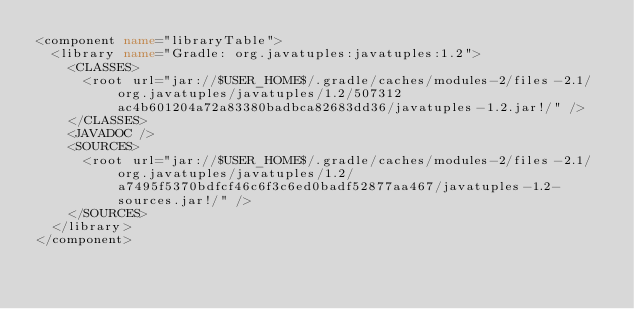<code> <loc_0><loc_0><loc_500><loc_500><_XML_><component name="libraryTable">
  <library name="Gradle: org.javatuples:javatuples:1.2">
    <CLASSES>
      <root url="jar://$USER_HOME$/.gradle/caches/modules-2/files-2.1/org.javatuples/javatuples/1.2/507312ac4b601204a72a83380badbca82683dd36/javatuples-1.2.jar!/" />
    </CLASSES>
    <JAVADOC />
    <SOURCES>
      <root url="jar://$USER_HOME$/.gradle/caches/modules-2/files-2.1/org.javatuples/javatuples/1.2/a7495f5370bdfcf46c6f3c6ed0badf52877aa467/javatuples-1.2-sources.jar!/" />
    </SOURCES>
  </library>
</component></code> 